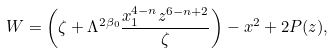Convert formula to latex. <formula><loc_0><loc_0><loc_500><loc_500>W = \left ( \zeta + \Lambda ^ { 2 \beta _ { 0 } } \frac { x _ { 1 } ^ { 4 - n } z ^ { 6 - n + 2 } } { \zeta } \right ) - x ^ { 2 } + 2 P ( z ) ,</formula> 